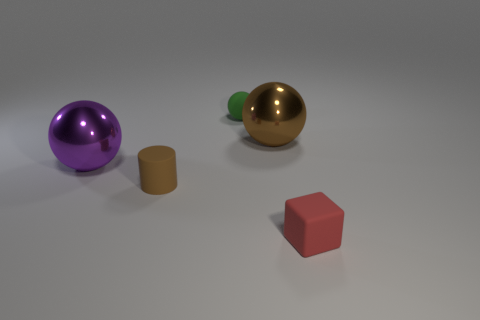Are there an equal number of brown spheres that are left of the purple sphere and blue cubes?
Offer a terse response. Yes. What is the color of the other small thing that is the same shape as the brown shiny object?
Provide a succinct answer. Green. How many tiny matte things have the same shape as the purple shiny object?
Make the answer very short. 1. There is a object that is the same color as the small matte cylinder; what material is it?
Your response must be concise. Metal. How many tiny green balls are there?
Provide a succinct answer. 1. Are there any other large purple things made of the same material as the purple object?
Provide a short and direct response. No. What is the size of the object that is the same color as the rubber cylinder?
Give a very brief answer. Large. Does the rubber object behind the matte cylinder have the same size as the matte block that is right of the small brown cylinder?
Your response must be concise. Yes. There is a brown thing that is behind the small brown thing; what size is it?
Make the answer very short. Large. Is there another small rubber sphere that has the same color as the tiny matte ball?
Ensure brevity in your answer.  No. 